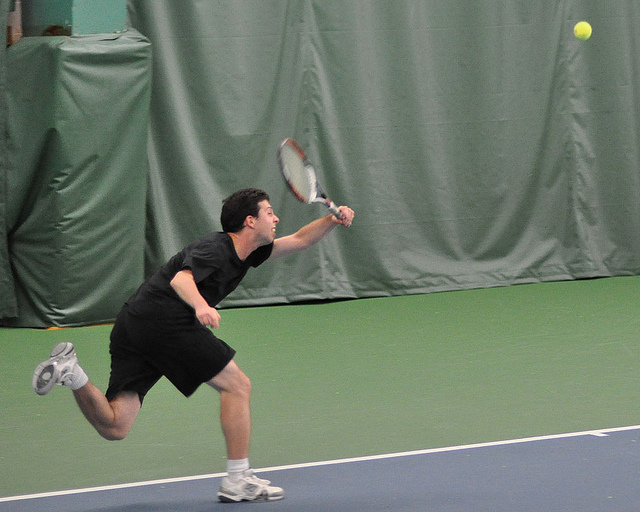<image>Is this man playing opposite to a female? It is unknown whether the man is playing opposite to a female. Is this man playing opposite to a female? I don't know if this man is playing opposite to a female. It is unclear based on the information given. 